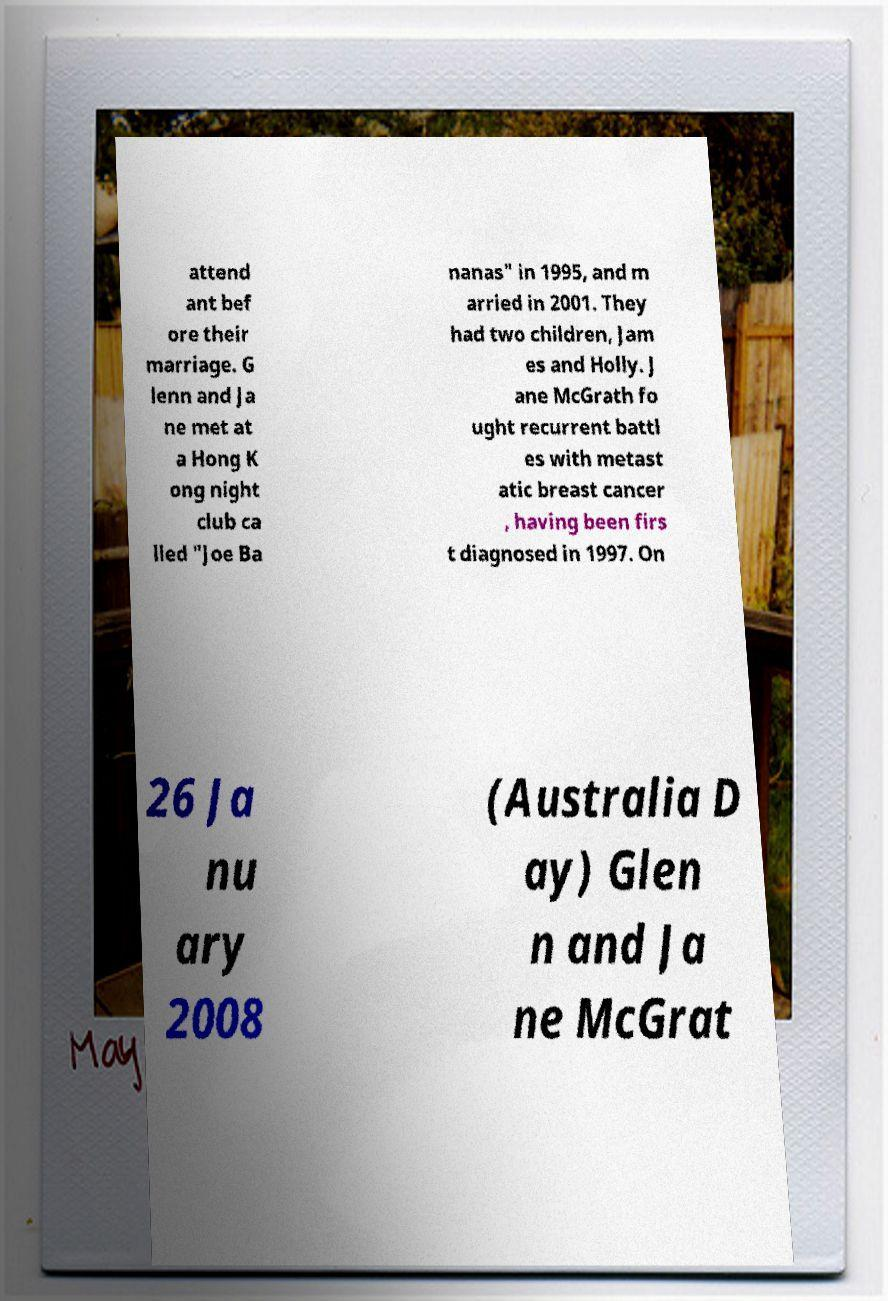Please read and relay the text visible in this image. What does it say? attend ant bef ore their marriage. G lenn and Ja ne met at a Hong K ong night club ca lled "Joe Ba nanas" in 1995, and m arried in 2001. They had two children, Jam es and Holly. J ane McGrath fo ught recurrent battl es with metast atic breast cancer , having been firs t diagnosed in 1997. On 26 Ja nu ary 2008 (Australia D ay) Glen n and Ja ne McGrat 